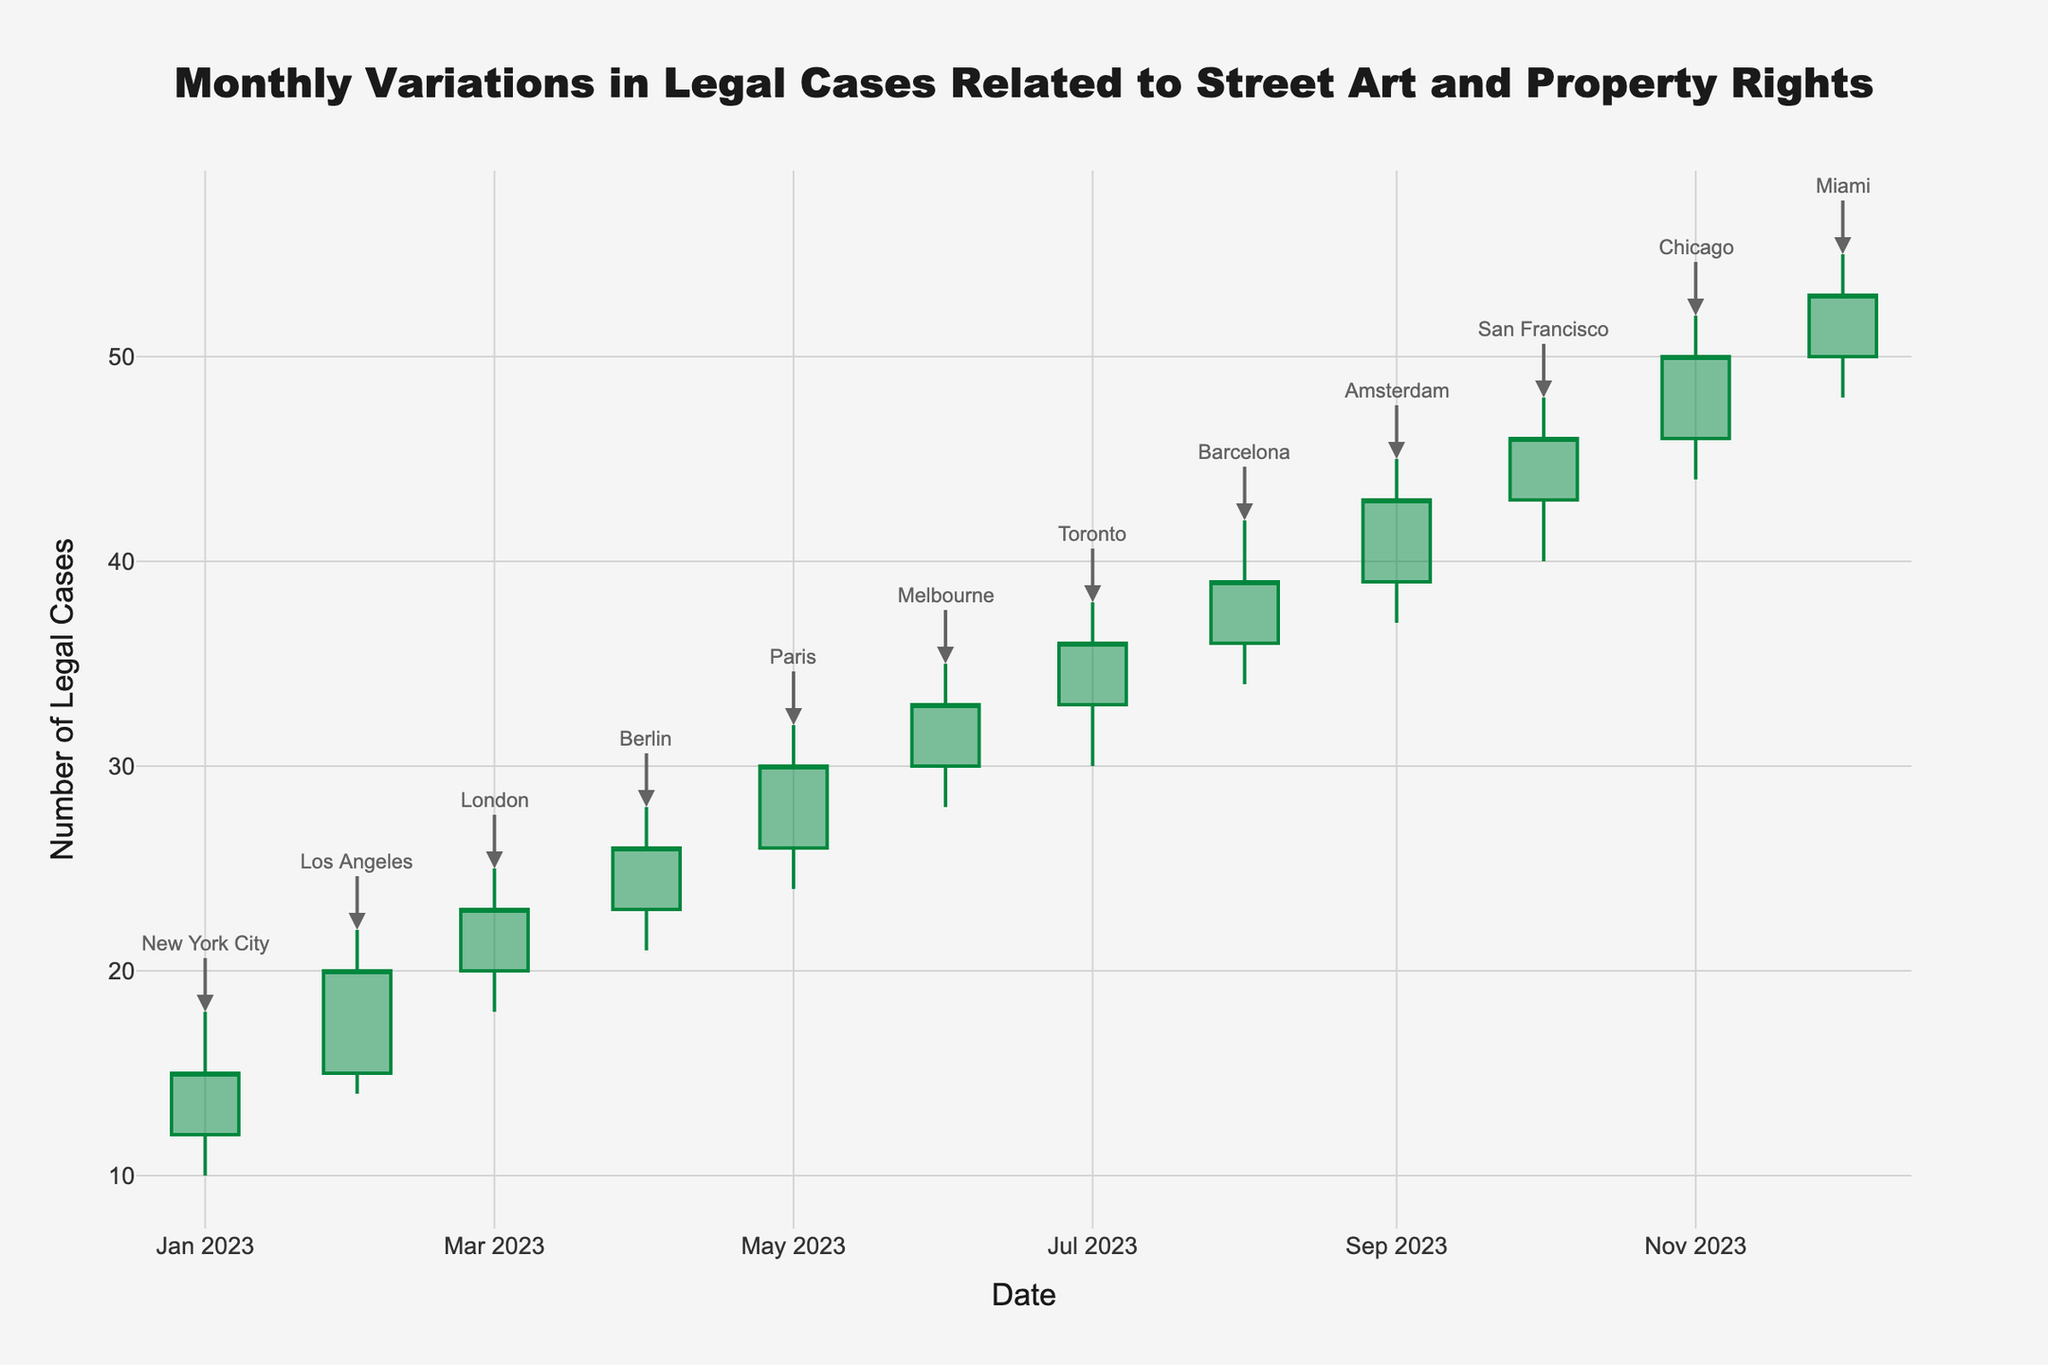what is the title of the plot? The title of the plot is usually at the top center of the figure. Reading it directly, we can see that it is "Monthly Variations in Legal Cases Related to Street Art and Property Rights".
Answer: Monthly Variations in Legal Cases Related to Street Art and Property Rights what colors are used to represent increasing and decreasing trends in the plot? Increasing and decreasing trends are represented by different colors. Green is for increasing trends, and red is for decreasing trends.
Answer: Green and red which month had the highest number of legal cases by the end of the month? To determine this, we look for the month with the highest closing value on the y-axis. In December, the closing value is 53, which is the highest among all months.
Answer: December how many jurisdictions are referenced in the plot? Each month is annotated with the name of a jurisdiction. Counting these annotations, there are 12 jurisdictions mentioned, corresponding to each month.
Answer: 12 which months recorded a decrease in legal cases from their opening to closing values? Decreases in legal cases are indicated by the red color. Checking the months, only January and February show a decrease (color red).
Answer: January and February what is the average closing value of legal cases over the 12 months? We sum up all closing values and divide by the total number of months. The sum is 15 + 20 + 23 + 26 + 30 + 33 + 36 + 39 + 43 + 46 + 50 + 53 = 414. The average is 414 / 12.
Answer: 34.5 which month had the greatest difference between its high and low values? We calculate the difference between high and low values for each month. The month with the highest difference is September, with a difference of 45 - 37 = 8.
Answer: September how does the legal case trend in Paris (May) compare to that in Amsterdam (September)? Comparing May and September, Paris has a closing value of 30 and Amsterdam has a closing value of 43. Thus, Amsterdam has a higher closing value.
Answer: Amsterdam what trends can be inferred from the increasing sequence of closing values from June to December? Observing the closing values from June (33) through December (53), there is a steadily increasing trend indicating consistent growth in legal cases.
Answer: Consistent growth which two jurisdictions had their closing values equal? To find equal closing values, we observe that Berlin in April and Barcelona in August both have the same closing value of 39.
Answer: Berlin and Barcelona 